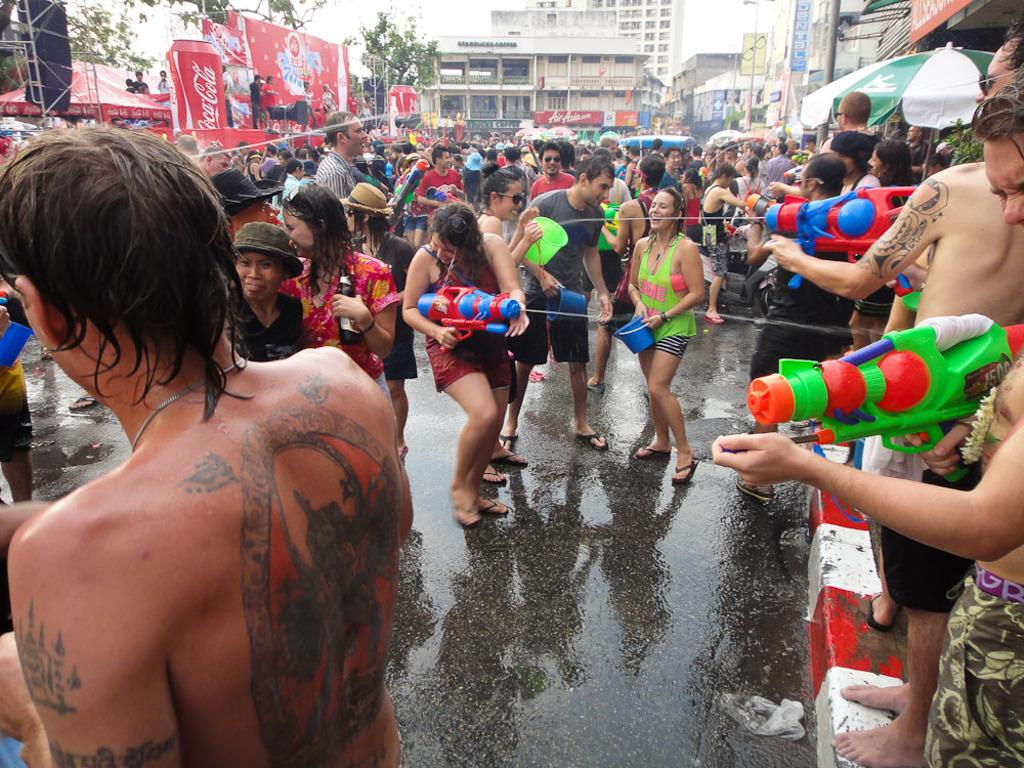What is the setting of the image? The image is an outside view. What are the people in the image doing? The people are standing on the road and playing with water. What can be seen in the background of the image? There are buildings and trees in the background of the image. What type of drain is visible in the image? There is no drain present in the image. What country is the image taken in? The provided facts do not specify the country where the image was taken. 